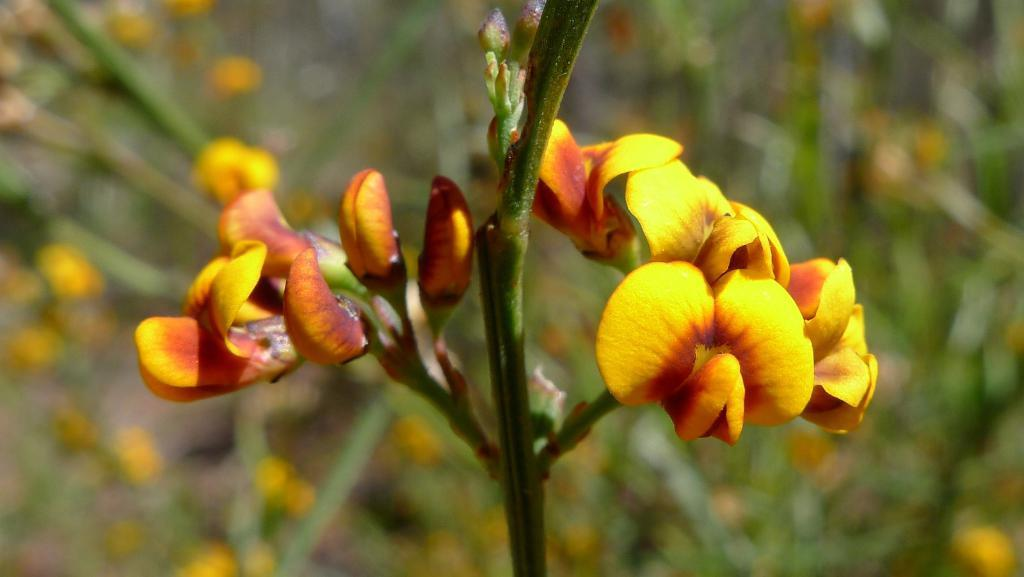What type of plant can be seen in the image? There is a plant with flowers in the image. Can you describe the background of the image? The background of the image is blurred. How many chairs are visible in the image? There are no chairs present in the image. What type of disease can be seen affecting the plant in the image? There is no disease affecting the plant in the image; it appears healthy with flowers. 